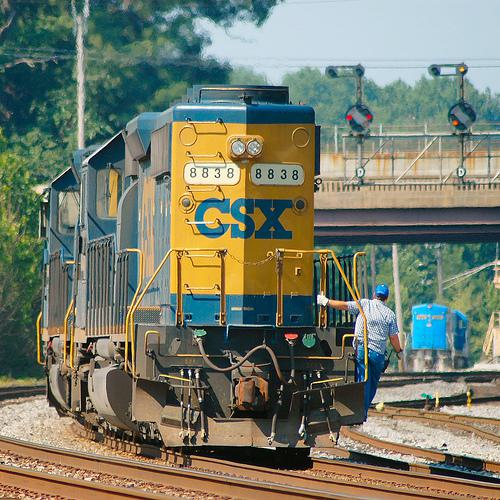Based on the image, can you tell if this train is arriving or departing? It is challenging to ascertain the direction of movement from a still image. However, considering the person beside the train is standing on the tracks and seems to be working rather than boarding, it is likely that the train is stopped, either having just arrived or preparing to depart. 